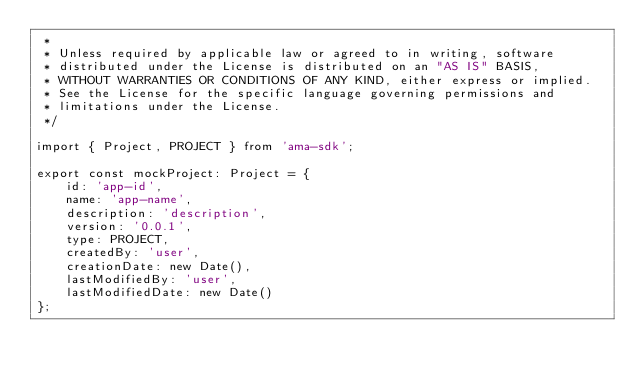Convert code to text. <code><loc_0><loc_0><loc_500><loc_500><_TypeScript_> *
 * Unless required by applicable law or agreed to in writing, software
 * distributed under the License is distributed on an "AS IS" BASIS,
 * WITHOUT WARRANTIES OR CONDITIONS OF ANY KIND, either express or implied.
 * See the License for the specific language governing permissions and
 * limitations under the License.
 */

import { Project, PROJECT } from 'ama-sdk';

export const mockProject: Project = {
    id: 'app-id',
    name: 'app-name',
    description: 'description',
    version: '0.0.1',
    type: PROJECT,
    createdBy: 'user',
    creationDate: new Date(),
    lastModifiedBy: 'user',
    lastModifiedDate: new Date()
};
</code> 